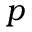Convert formula to latex. <formula><loc_0><loc_0><loc_500><loc_500>p</formula> 